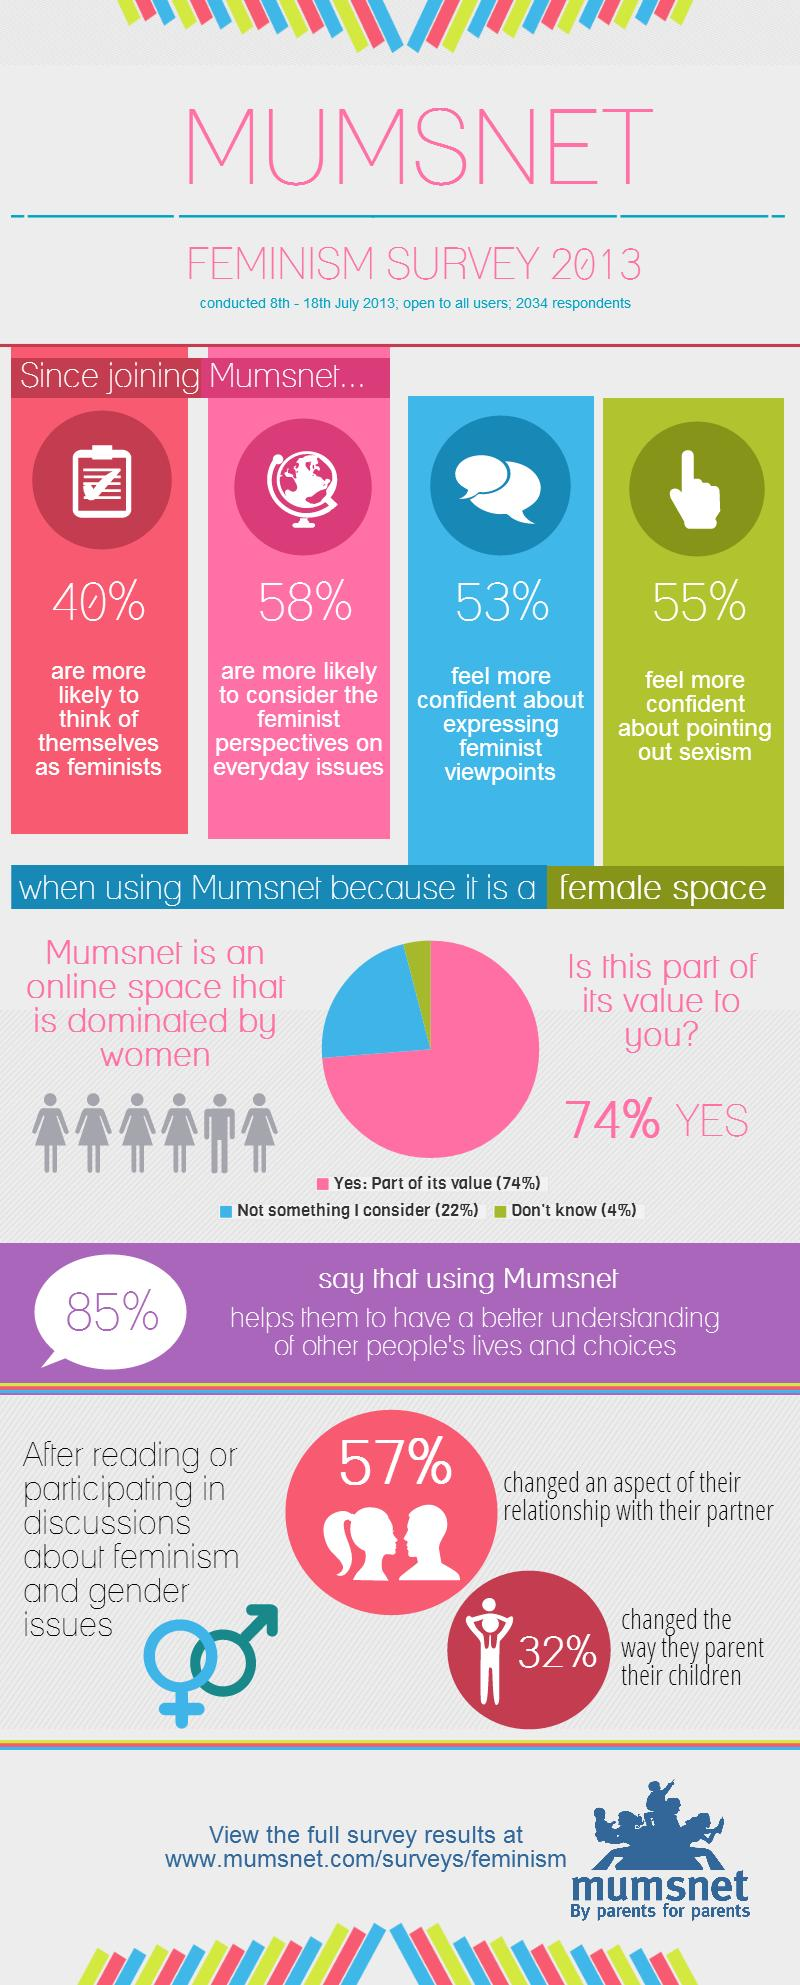Mention a couple of crucial points in this snapshot. According to the feminism survey conducted in 2013, 53% of the respondents reported feeling more confident about expressing their feminist viewpoints since joining the Mumsnet community. According to the feminism survey conducted by Mumsnet in 2013, 55% of respondents reported feeling more confident in pointing out sexism since joining the platform. In the Mumsnet community, 40% of respondents are more likely to identify as feminists since joining the platform, according to a survey conducted in 2013. According to the data, 32% of individuals changed the way they parent their children after engaging in discussions or reading about feminism and gender issues. 